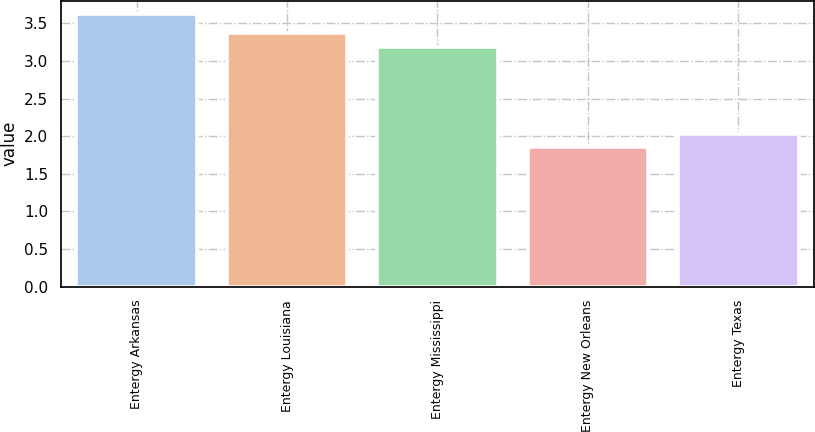Convert chart. <chart><loc_0><loc_0><loc_500><loc_500><bar_chart><fcel>Entergy Arkansas<fcel>Entergy Louisiana<fcel>Entergy Mississippi<fcel>Entergy New Orleans<fcel>Entergy Texas<nl><fcel>3.62<fcel>3.37<fcel>3.19<fcel>1.85<fcel>2.03<nl></chart> 